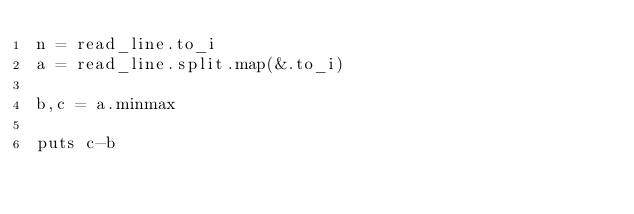Convert code to text. <code><loc_0><loc_0><loc_500><loc_500><_Crystal_>n = read_line.to_i
a = read_line.split.map(&.to_i)

b,c = a.minmax

puts c-b</code> 